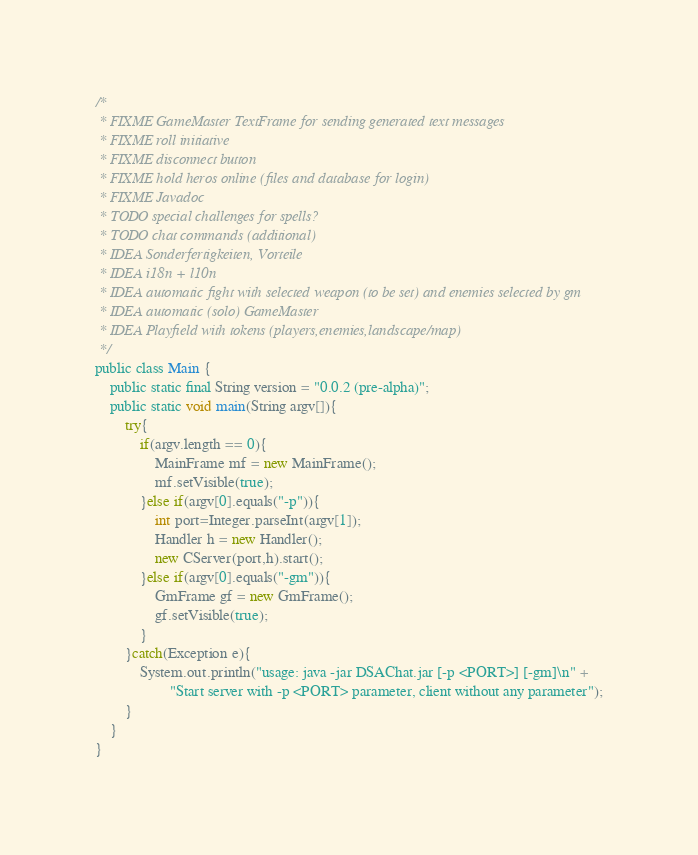Convert code to text. <code><loc_0><loc_0><loc_500><loc_500><_Java_>/*
 * FIXME GameMaster TextFrame for sending generated text messages
 * FIXME roll initiative
 * FIXME disconnect button
 * FIXME hold heros online (files and database for login)
 * FIXME Javadoc
 * TODO special challenges for spells?
 * TODO chat commands (additional)
 * IDEA Sonderfertigkeiten, Vorteile
 * IDEA i18n + l10n
 * IDEA automatic fight with selected weapon (to be set) and enemies selected by gm
 * IDEA automatic (solo) GameMaster
 * IDEA Playfield with tokens (players,enemies,landscape/map)
 */
public class Main {
	public static final String version = "0.0.2 (pre-alpha)"; 
	public static void main(String argv[]){
		try{
		    if(argv.length == 0){
		    	MainFrame mf = new MainFrame();
	    		mf.setVisible(true);
		    }else if(argv[0].equals("-p")){
	    		int port=Integer.parseInt(argv[1]);
	    		Handler h = new Handler();
	    		new CServer(port,h).start();
		    }else if(argv[0].equals("-gm")){
		    	GmFrame gf = new GmFrame();
				gf.setVisible(true);
		    }
		}catch(Exception e){
			System.out.println("usage: java -jar DSAChat.jar [-p <PORT>] [-gm]\n" +
					"Start server with -p <PORT> parameter, client without any parameter");
		}
	}
}
</code> 